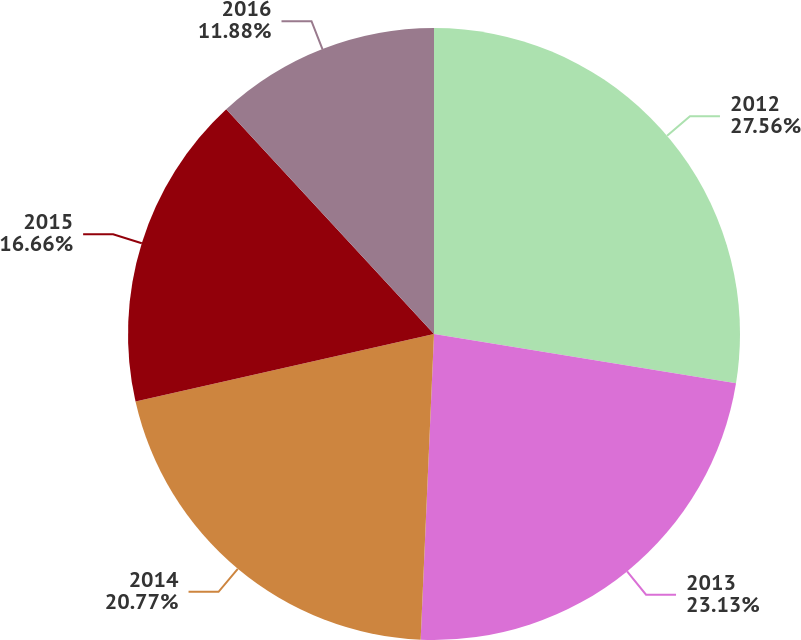<chart> <loc_0><loc_0><loc_500><loc_500><pie_chart><fcel>2012<fcel>2013<fcel>2014<fcel>2015<fcel>2016<nl><fcel>27.57%<fcel>23.13%<fcel>20.77%<fcel>16.66%<fcel>11.88%<nl></chart> 